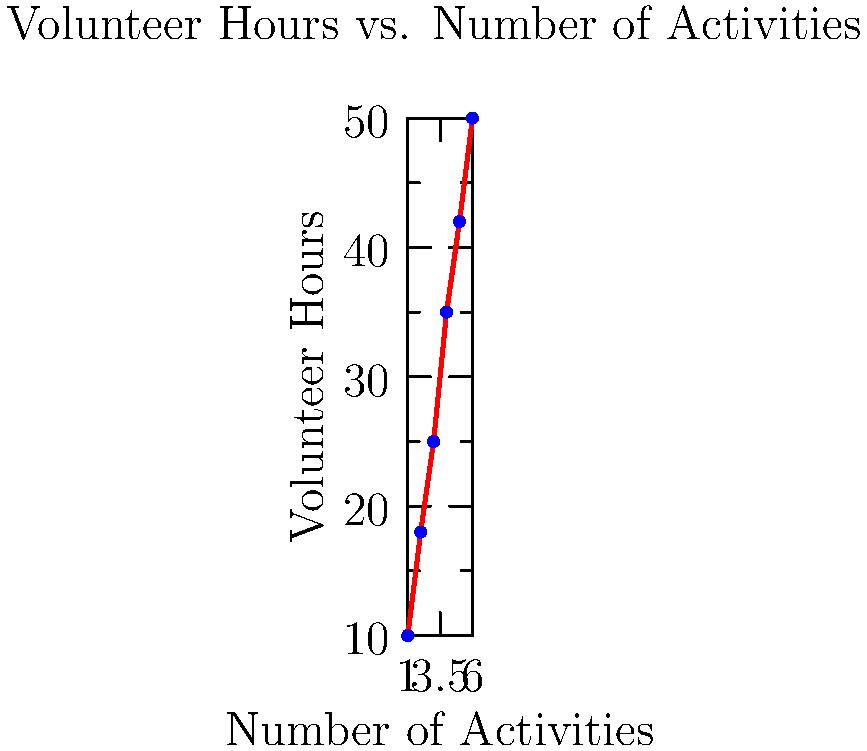As the rotary club's fundraising coordinator, you're planning a community outreach event. Using the scatter plot provided, which shows the relationship between the number of activities and volunteer hours needed, estimate the number of volunteer hours required if you plan to have 7 activities at the event. To estimate the number of volunteer hours needed for 7 activities, we'll follow these steps:

1. Observe the trend in the scatter plot: There's a clear positive linear relationship between the number of activities and volunteer hours.

2. Identify the pattern: The number of volunteer hours increases by approximately 8-10 hours for each additional activity.

3. Find the last known data point: 6 activities require 50 volunteer hours.

4. Estimate the increase for one more activity:
   The average increase per activity is about 9 hours (50 hours - 10 hours) / (6 activities - 1 activity) = 8.8 hours, rounded to 9.

5. Calculate the estimate for 7 activities:
   50 hours (for 6 activities) + 9 hours (for the 7th activity) = 59 hours

Therefore, we can estimate that approximately 59 volunteer hours would be needed for 7 activities.
Answer: 59 hours 